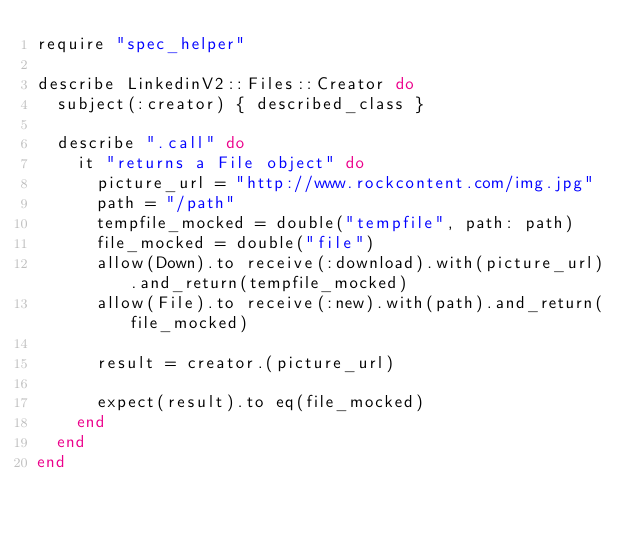Convert code to text. <code><loc_0><loc_0><loc_500><loc_500><_Ruby_>require "spec_helper"

describe LinkedinV2::Files::Creator do
  subject(:creator) { described_class }

  describe ".call" do
    it "returns a File object" do
      picture_url = "http://www.rockcontent.com/img.jpg"
      path = "/path"
      tempfile_mocked = double("tempfile", path: path)
      file_mocked = double("file")
      allow(Down).to receive(:download).with(picture_url).and_return(tempfile_mocked)
      allow(File).to receive(:new).with(path).and_return(file_mocked)

      result = creator.(picture_url)

      expect(result).to eq(file_mocked)
    end
  end
end
</code> 